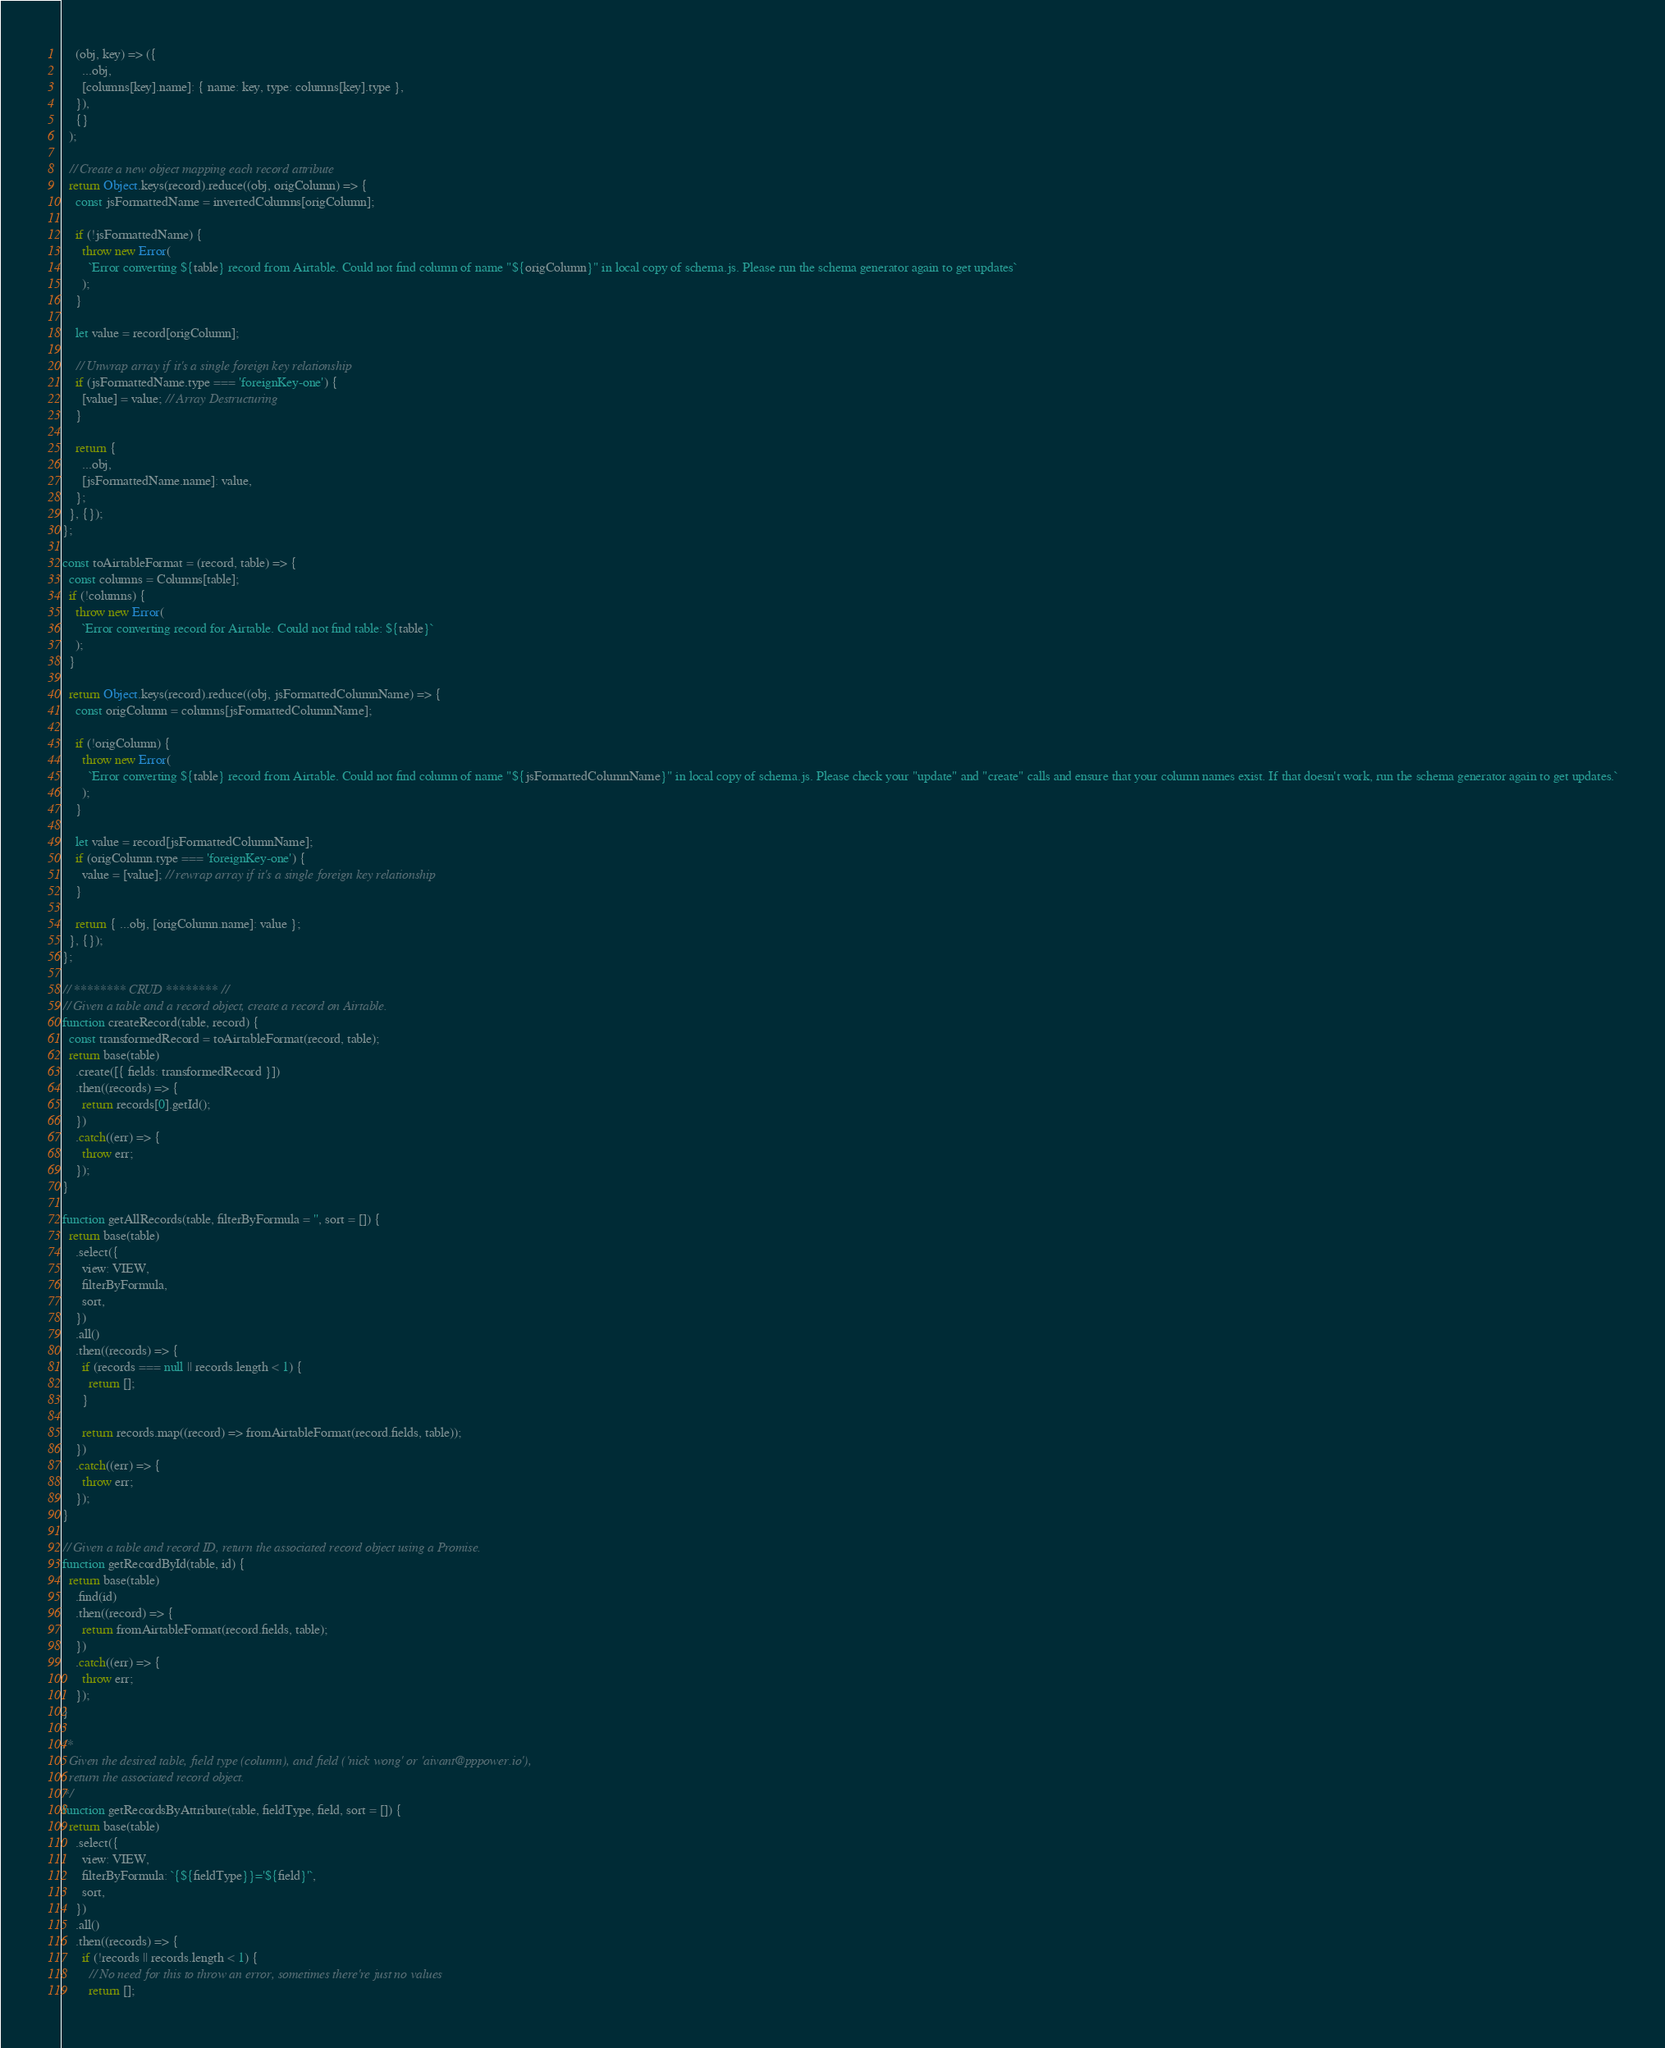Convert code to text. <code><loc_0><loc_0><loc_500><loc_500><_JavaScript_>    (obj, key) => ({
      ...obj,
      [columns[key].name]: { name: key, type: columns[key].type },
    }),
    {}
  );

  // Create a new object mapping each record attribute
  return Object.keys(record).reduce((obj, origColumn) => {
    const jsFormattedName = invertedColumns[origColumn];

    if (!jsFormattedName) {
      throw new Error(
        `Error converting ${table} record from Airtable. Could not find column of name "${origColumn}" in local copy of schema.js. Please run the schema generator again to get updates`
      );
    }

    let value = record[origColumn];

    // Unwrap array if it's a single foreign key relationship
    if (jsFormattedName.type === 'foreignKey-one') {
      [value] = value; // Array Destructuring
    }

    return {
      ...obj,
      [jsFormattedName.name]: value,
    };
  }, {});
};

const toAirtableFormat = (record, table) => {
  const columns = Columns[table];
  if (!columns) {
    throw new Error(
      `Error converting record for Airtable. Could not find table: ${table}`
    );
  }

  return Object.keys(record).reduce((obj, jsFormattedColumnName) => {
    const origColumn = columns[jsFormattedColumnName];

    if (!origColumn) {
      throw new Error(
        `Error converting ${table} record from Airtable. Could not find column of name "${jsFormattedColumnName}" in local copy of schema.js. Please check your "update" and "create" calls and ensure that your column names exist. If that doesn't work, run the schema generator again to get updates.`
      );
    }

    let value = record[jsFormattedColumnName];
    if (origColumn.type === 'foreignKey-one') {
      value = [value]; // rewrap array if it's a single foreign key relationship
    }

    return { ...obj, [origColumn.name]: value };
  }, {});
};

// ******** CRUD ******** //
// Given a table and a record object, create a record on Airtable.
function createRecord(table, record) {
  const transformedRecord = toAirtableFormat(record, table);
  return base(table)
    .create([{ fields: transformedRecord }])
    .then((records) => {
      return records[0].getId();
    })
    .catch((err) => {
      throw err;
    });
}

function getAllRecords(table, filterByFormula = '', sort = []) {
  return base(table)
    .select({
      view: VIEW,
      filterByFormula,
      sort,
    })
    .all()
    .then((records) => {
      if (records === null || records.length < 1) {
        return [];
      }

      return records.map((record) => fromAirtableFormat(record.fields, table));
    })
    .catch((err) => {
      throw err;
    });
}

// Given a table and record ID, return the associated record object using a Promise.
function getRecordById(table, id) {
  return base(table)
    .find(id)
    .then((record) => {
      return fromAirtableFormat(record.fields, table);
    })
    .catch((err) => {
      throw err;
    });
}

/*
  Given the desired table, field type (column), and field ('nick wong' or 'aivant@pppower.io'),
  return the associated record object.
*/
function getRecordsByAttribute(table, fieldType, field, sort = []) {
  return base(table)
    .select({
      view: VIEW,
      filterByFormula: `{${fieldType}}='${field}'`,
      sort,
    })
    .all()
    .then((records) => {
      if (!records || records.length < 1) {
        // No need for this to throw an error, sometimes there're just no values
        return [];</code> 